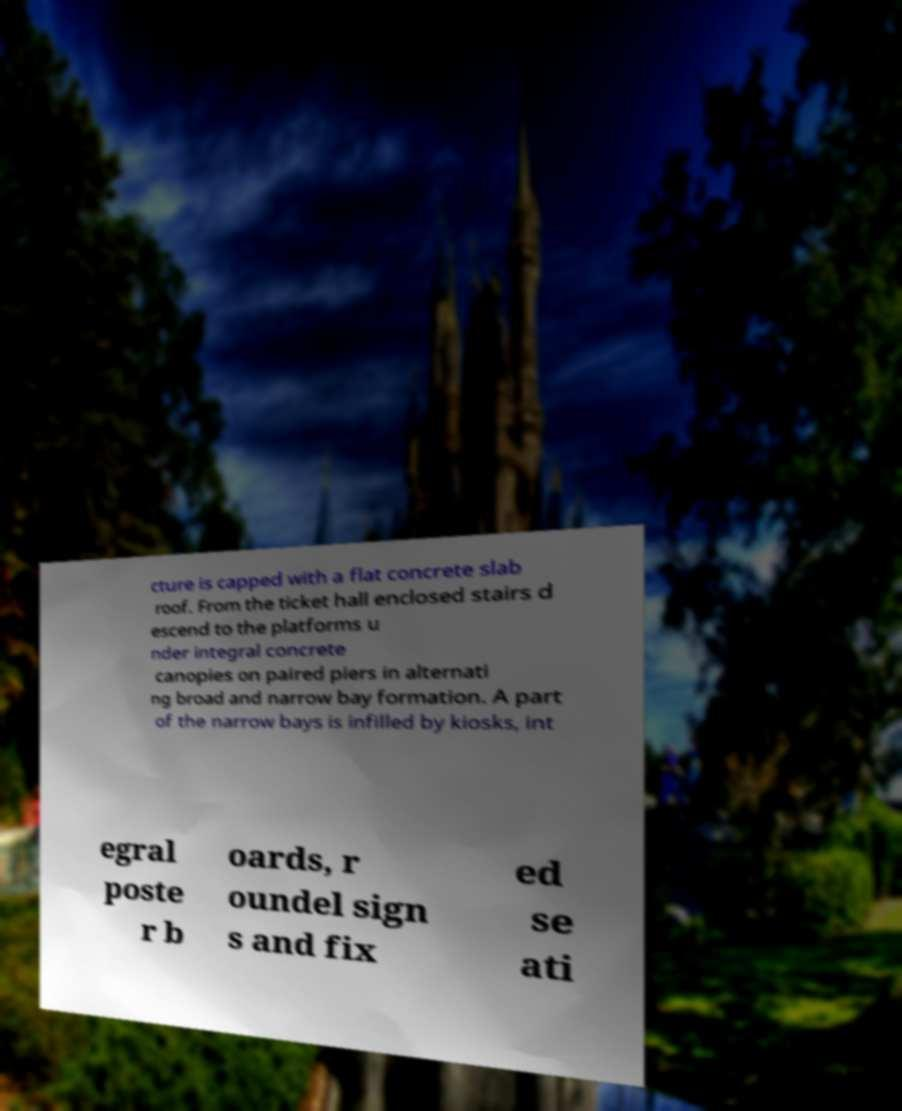Could you extract and type out the text from this image? cture is capped with a flat concrete slab roof. From the ticket hall enclosed stairs d escend to the platforms u nder integral concrete canopies on paired piers in alternati ng broad and narrow bay formation. A part of the narrow bays is infilled by kiosks, int egral poste r b oards, r oundel sign s and fix ed se ati 